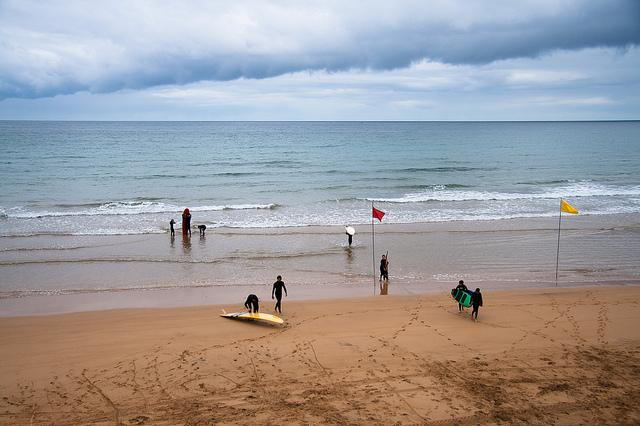What does the red flag mean? danger 